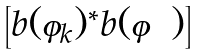<formula> <loc_0><loc_0><loc_500><loc_500>\begin{bmatrix} b ( \varphi _ { k } ) ^ { * } b ( \varphi ) \end{bmatrix}</formula> 